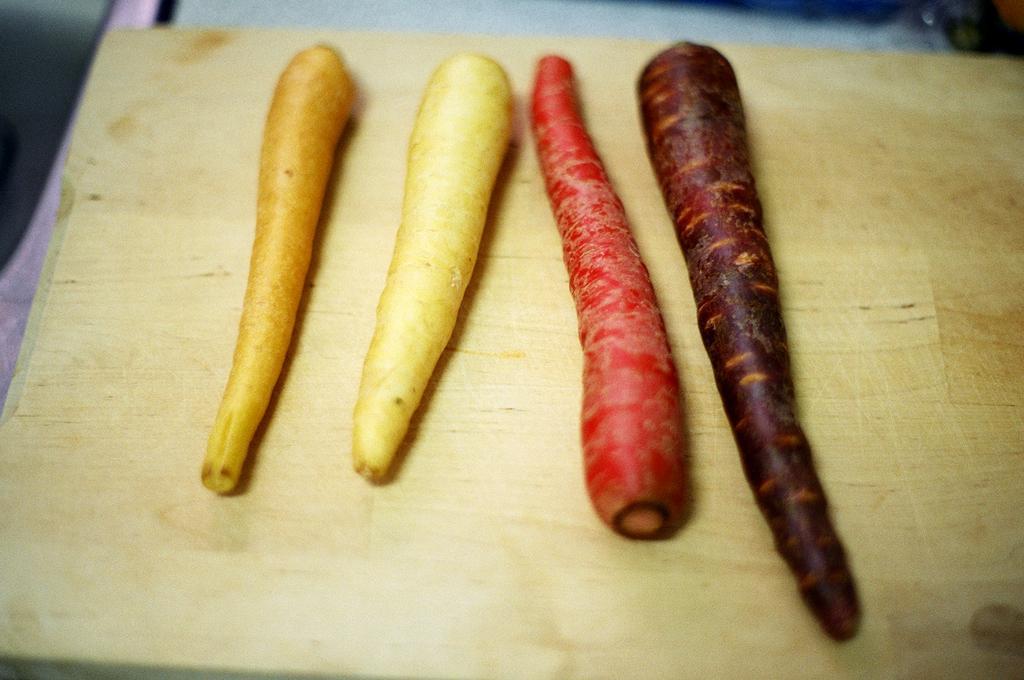Describe this image in one or two sentences. In this image I can see few carrots in cream,red,brown and white color. The carrots are on the brown color board. 